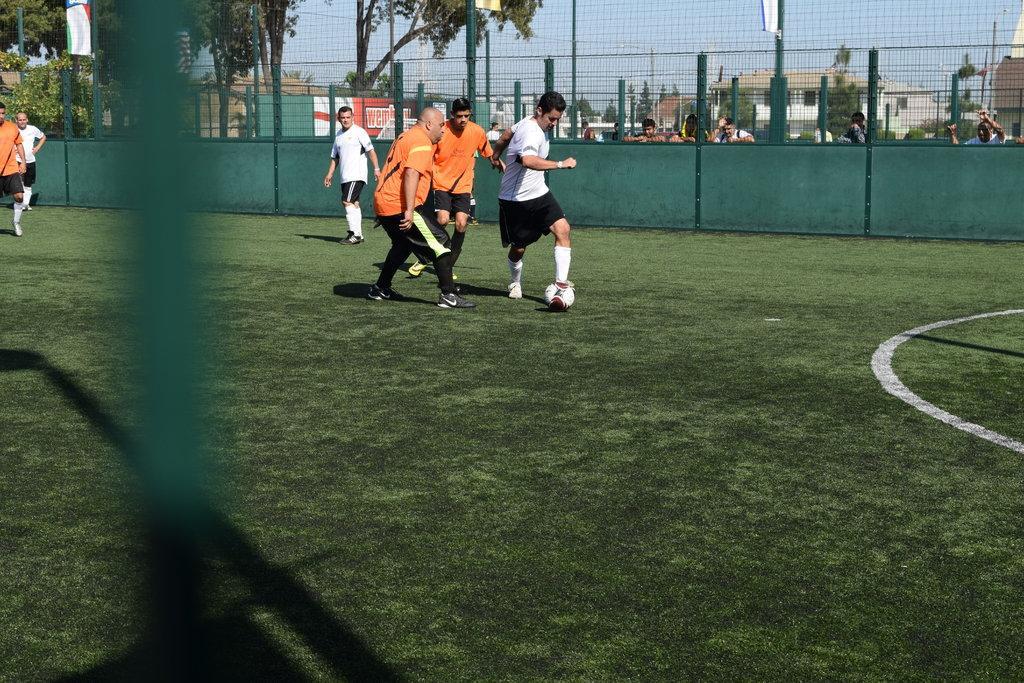Describe this image in one or two sentences. There are few men playing football on a grass field, it had a fence and outside the fence there are some people watching them and on the background there are trees,home and sky over the top. 